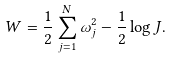<formula> <loc_0><loc_0><loc_500><loc_500>W = \frac { 1 } { 2 } \sum _ { j = 1 } ^ { N } \omega _ { j } ^ { 2 } - \frac { 1 } { 2 } \log J .</formula> 